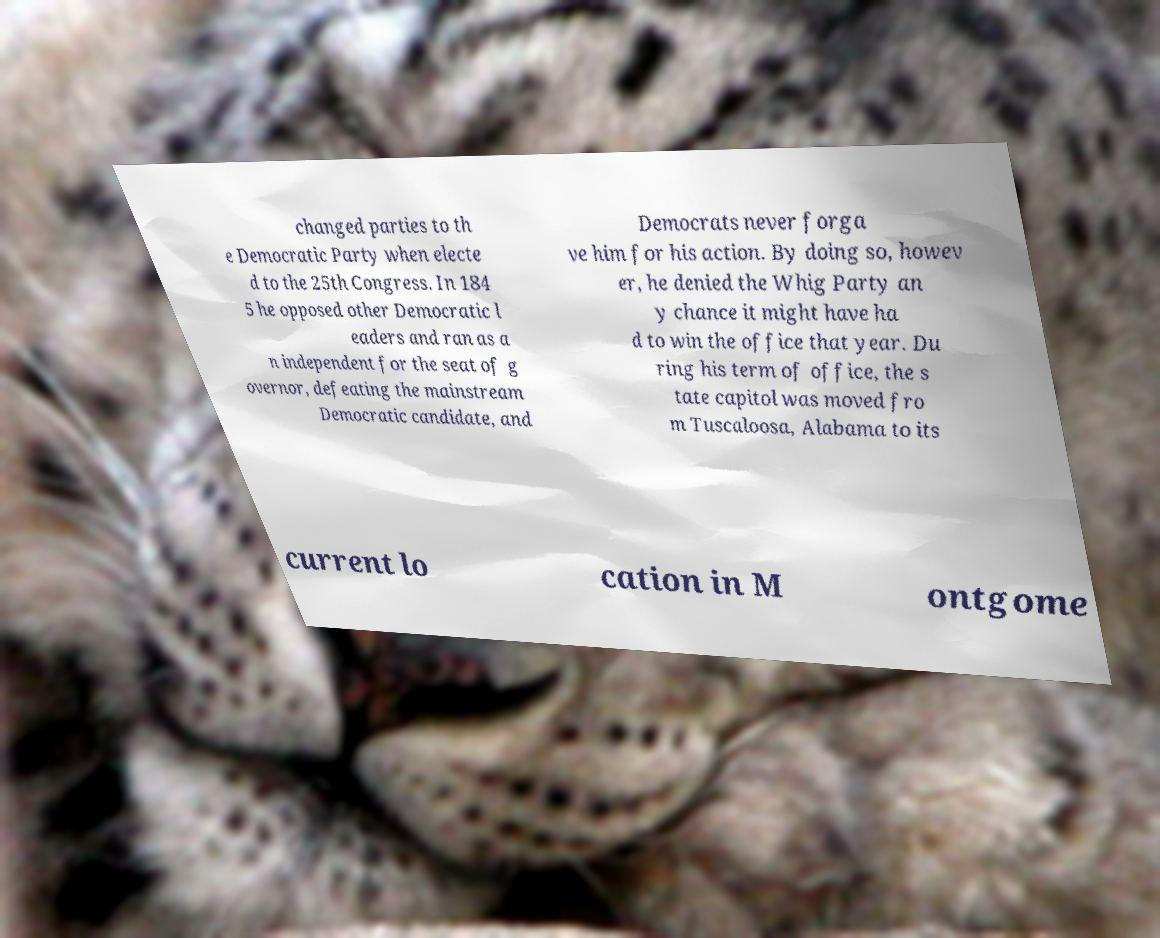Please identify and transcribe the text found in this image. changed parties to th e Democratic Party when electe d to the 25th Congress. In 184 5 he opposed other Democratic l eaders and ran as a n independent for the seat of g overnor, defeating the mainstream Democratic candidate, and Democrats never forga ve him for his action. By doing so, howev er, he denied the Whig Party an y chance it might have ha d to win the office that year. Du ring his term of office, the s tate capitol was moved fro m Tuscaloosa, Alabama to its current lo cation in M ontgome 